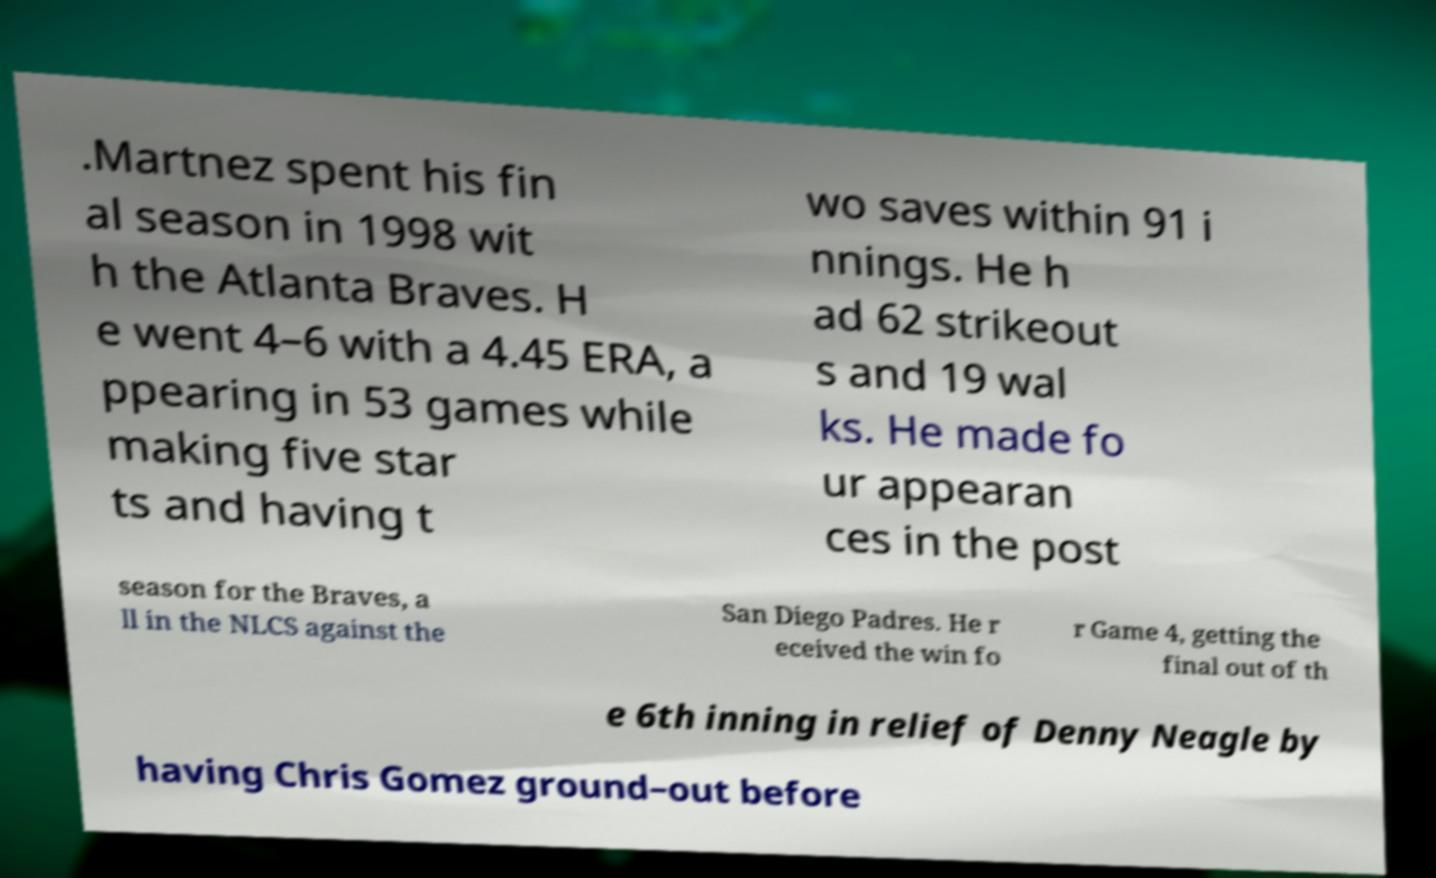For documentation purposes, I need the text within this image transcribed. Could you provide that? .Martnez spent his fin al season in 1998 wit h the Atlanta Braves. H e went 4–6 with a 4.45 ERA, a ppearing in 53 games while making five star ts and having t wo saves within 91 i nnings. He h ad 62 strikeout s and 19 wal ks. He made fo ur appearan ces in the post season for the Braves, a ll in the NLCS against the San Diego Padres. He r eceived the win fo r Game 4, getting the final out of th e 6th inning in relief of Denny Neagle by having Chris Gomez ground–out before 